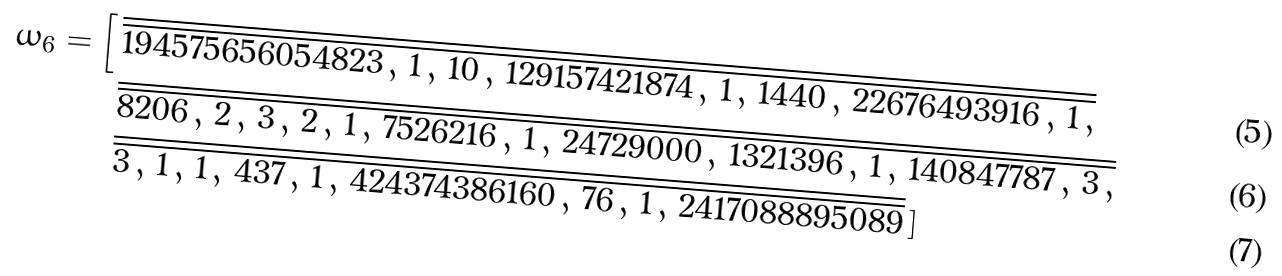Convert formula to latex. <formula><loc_0><loc_0><loc_500><loc_500>\omega _ { 6 } = \Big [ \, & \overline { \overline { 1 9 4 5 7 5 6 5 6 0 5 4 8 2 3 \, , \, 1 \, , \, 1 0 \, , \, 1 2 9 1 5 7 4 2 1 8 7 4 \, , \, 1 \, , \, 1 4 4 0 \, , \, 2 2 6 7 6 4 9 3 9 1 6 \, , \, 1 \, , } } \\ & \overline { \overline { 8 2 0 6 \, , \, 2 \, , \, 3 \, , \, 2 \, , \, 1 \, , \, 7 5 2 6 2 1 6 \, , \, 1 \, , \, 2 4 7 2 9 0 0 0 \, , \, 1 3 2 1 3 9 6 \, , \, 1 \, , \, 1 4 0 8 4 7 7 8 7 \, , \, 3 \, , } } \\ & \overline { \overline { 3 \, , \, 1 \, , \, 1 \, , \, 4 3 7 \, , \, 1 \, , \, 4 2 4 3 7 4 3 8 6 1 6 0 \, , \, 7 6 \, , \, 1 \, , \, 2 4 1 7 0 8 8 8 9 5 0 8 9 } } \, ]</formula> 